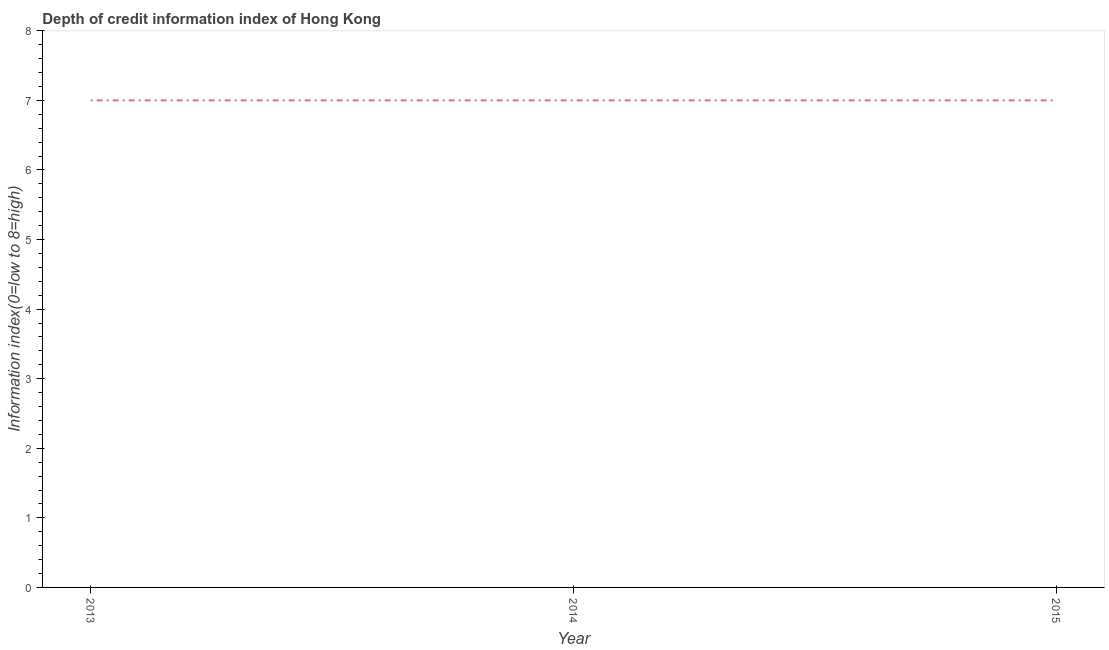What is the depth of credit information index in 2013?
Offer a terse response. 7. Across all years, what is the maximum depth of credit information index?
Provide a short and direct response. 7. Across all years, what is the minimum depth of credit information index?
Keep it short and to the point. 7. In which year was the depth of credit information index minimum?
Provide a succinct answer. 2013. What is the sum of the depth of credit information index?
Provide a short and direct response. 21. What is the ratio of the depth of credit information index in 2014 to that in 2015?
Provide a succinct answer. 1. Is the sum of the depth of credit information index in 2014 and 2015 greater than the maximum depth of credit information index across all years?
Your response must be concise. Yes. What is the difference between the highest and the lowest depth of credit information index?
Ensure brevity in your answer.  0. Does the depth of credit information index monotonically increase over the years?
Your answer should be very brief. No. How many lines are there?
Provide a short and direct response. 1. How many years are there in the graph?
Ensure brevity in your answer.  3. What is the difference between two consecutive major ticks on the Y-axis?
Provide a succinct answer. 1. Are the values on the major ticks of Y-axis written in scientific E-notation?
Provide a short and direct response. No. Does the graph contain any zero values?
Give a very brief answer. No. What is the title of the graph?
Provide a short and direct response. Depth of credit information index of Hong Kong. What is the label or title of the Y-axis?
Ensure brevity in your answer.  Information index(0=low to 8=high). What is the Information index(0=low to 8=high) in 2013?
Keep it short and to the point. 7. What is the Information index(0=low to 8=high) in 2014?
Keep it short and to the point. 7. What is the Information index(0=low to 8=high) of 2015?
Your response must be concise. 7. What is the difference between the Information index(0=low to 8=high) in 2013 and 2014?
Offer a very short reply. 0. What is the difference between the Information index(0=low to 8=high) in 2014 and 2015?
Ensure brevity in your answer.  0. 